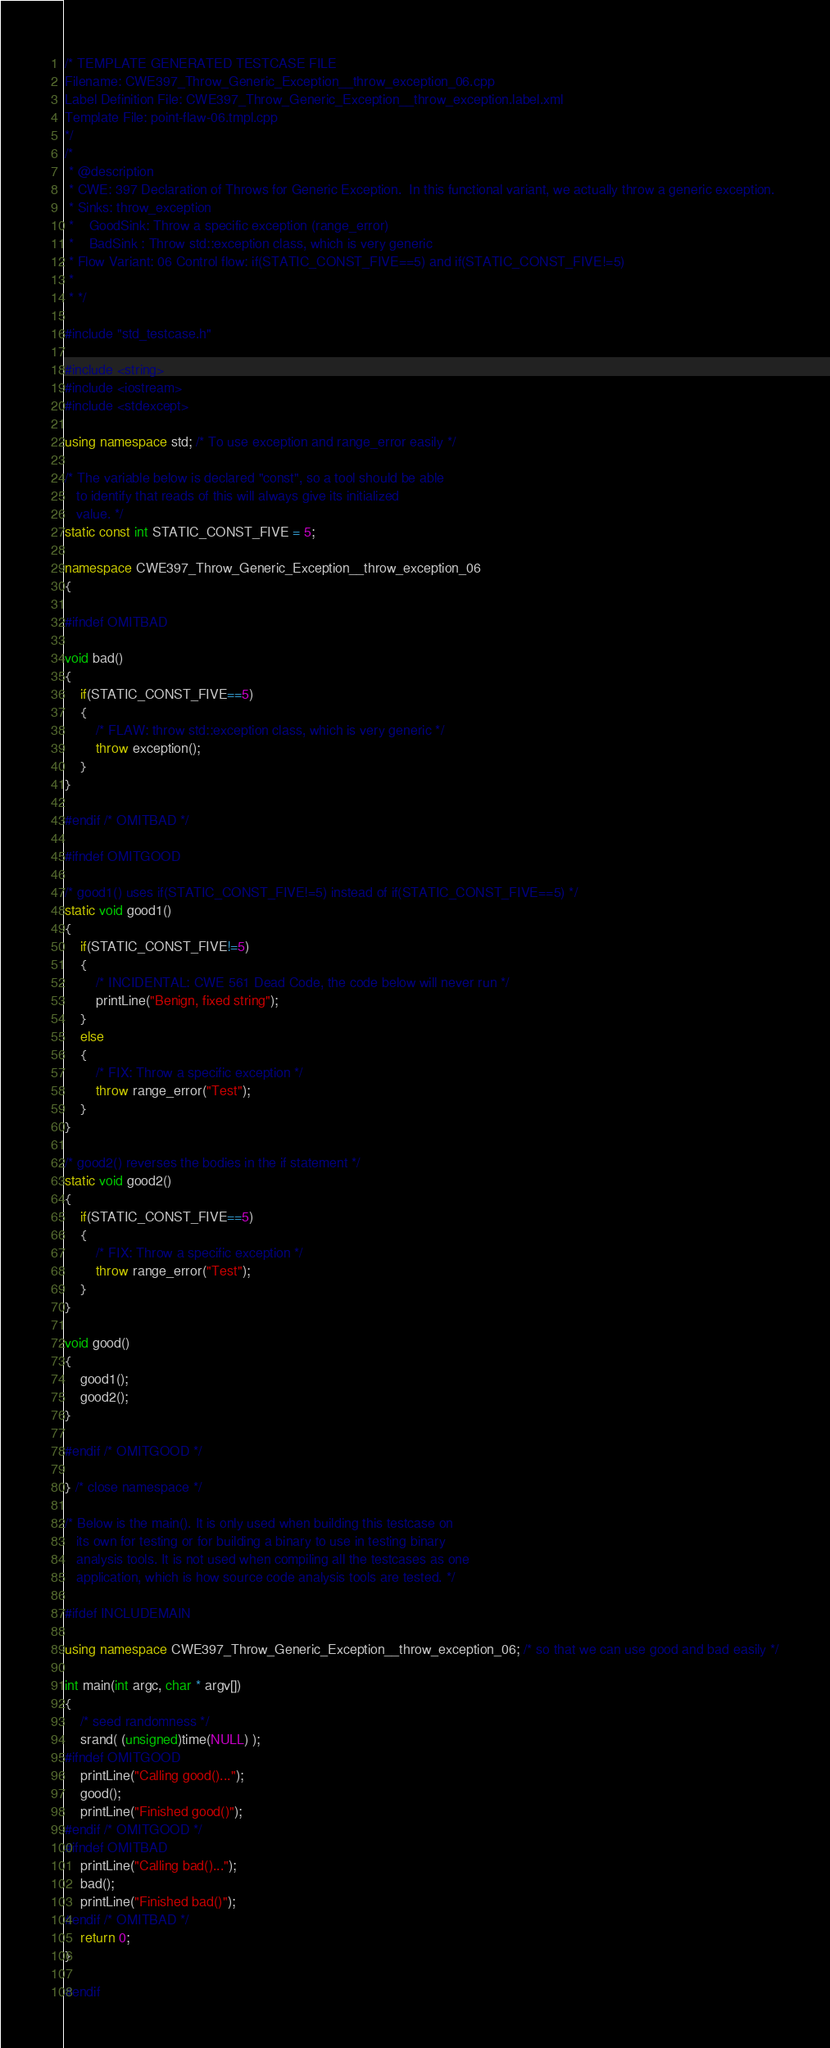<code> <loc_0><loc_0><loc_500><loc_500><_C++_>/* TEMPLATE GENERATED TESTCASE FILE
Filename: CWE397_Throw_Generic_Exception__throw_exception_06.cpp
Label Definition File: CWE397_Throw_Generic_Exception__throw_exception.label.xml
Template File: point-flaw-06.tmpl.cpp
*/
/*
 * @description
 * CWE: 397 Declaration of Throws for Generic Exception.  In this functional variant, we actually throw a generic exception.
 * Sinks: throw_exception
 *    GoodSink: Throw a specific exception (range_error)
 *    BadSink : Throw std::exception class, which is very generic
 * Flow Variant: 06 Control flow: if(STATIC_CONST_FIVE==5) and if(STATIC_CONST_FIVE!=5)
 *
 * */

#include "std_testcase.h"

#include <string>
#include <iostream>
#include <stdexcept>

using namespace std; /* To use exception and range_error easily */

/* The variable below is declared "const", so a tool should be able
   to identify that reads of this will always give its initialized
   value. */
static const int STATIC_CONST_FIVE = 5;

namespace CWE397_Throw_Generic_Exception__throw_exception_06
{

#ifndef OMITBAD

void bad()
{
    if(STATIC_CONST_FIVE==5)
    {
        /* FLAW: throw std::exception class, which is very generic */
        throw exception();
    }
}

#endif /* OMITBAD */

#ifndef OMITGOOD

/* good1() uses if(STATIC_CONST_FIVE!=5) instead of if(STATIC_CONST_FIVE==5) */
static void good1()
{
    if(STATIC_CONST_FIVE!=5)
    {
        /* INCIDENTAL: CWE 561 Dead Code, the code below will never run */
        printLine("Benign, fixed string");
    }
    else
    {
        /* FIX: Throw a specific exception */
        throw range_error("Test");
    }
}

/* good2() reverses the bodies in the if statement */
static void good2()
{
    if(STATIC_CONST_FIVE==5)
    {
        /* FIX: Throw a specific exception */
        throw range_error("Test");
    }
}

void good()
{
    good1();
    good2();
}

#endif /* OMITGOOD */

} /* close namespace */

/* Below is the main(). It is only used when building this testcase on
   its own for testing or for building a binary to use in testing binary
   analysis tools. It is not used when compiling all the testcases as one
   application, which is how source code analysis tools are tested. */

#ifdef INCLUDEMAIN

using namespace CWE397_Throw_Generic_Exception__throw_exception_06; /* so that we can use good and bad easily */

int main(int argc, char * argv[])
{
    /* seed randomness */
    srand( (unsigned)time(NULL) );
#ifndef OMITGOOD
    printLine("Calling good()...");
    good();
    printLine("Finished good()");
#endif /* OMITGOOD */
#ifndef OMITBAD
    printLine("Calling bad()...");
    bad();
    printLine("Finished bad()");
#endif /* OMITBAD */
    return 0;
}

#endif
</code> 